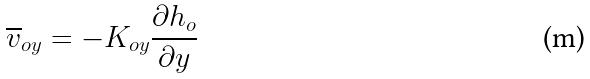Convert formula to latex. <formula><loc_0><loc_0><loc_500><loc_500>\overline { v } _ { o y } = - K _ { o y } \frac { \partial h _ { o } } { \partial y }</formula> 